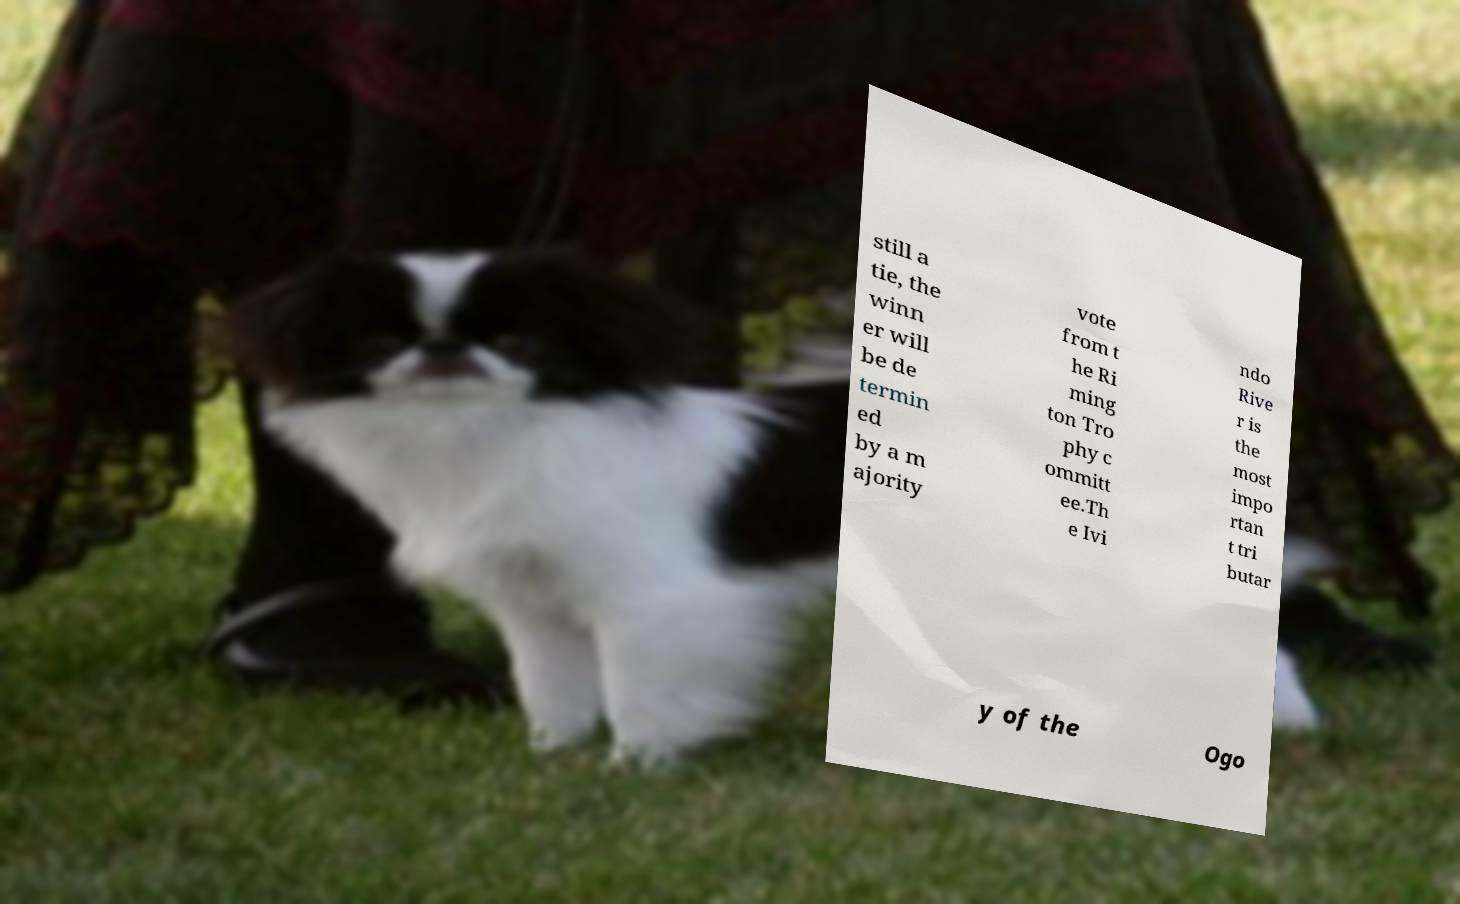Please read and relay the text visible in this image. What does it say? still a tie, the winn er will be de termin ed by a m ajority vote from t he Ri ming ton Tro phy c ommitt ee.Th e Ivi ndo Rive r is the most impo rtan t tri butar y of the Ogo 